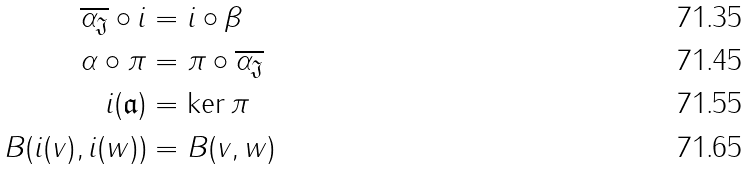Convert formula to latex. <formula><loc_0><loc_0><loc_500><loc_500>\overline { \alpha _ { \mathfrak J } } \circ i & = i \circ \beta \\ \alpha \circ \pi & = \pi \circ \overline { \alpha _ { \mathfrak J } } \\ i ( \mathfrak { a } ) & = \ker \pi \\ B ( i ( v ) , i ( w ) ) & = B ( v , w )</formula> 